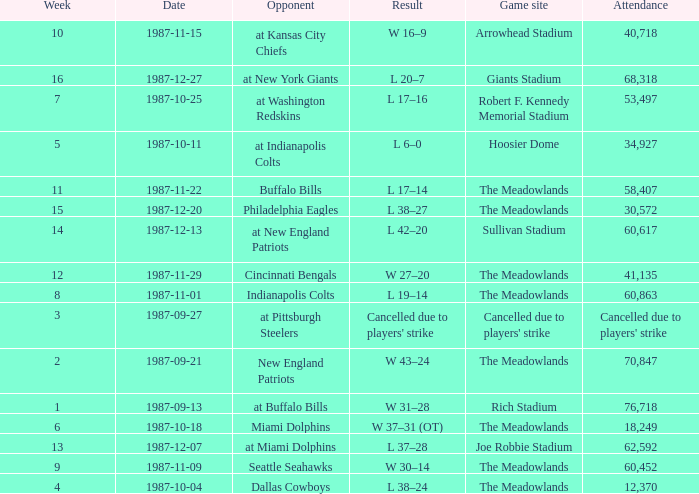Who did the Jets play in their pre-week 9 game at the Robert F. Kennedy memorial stadium? At washington redskins. 